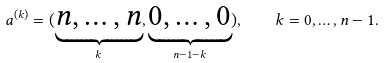<formula> <loc_0><loc_0><loc_500><loc_500>\ a ^ { ( k ) } = ( \underbrace { n , \dots , n } _ { k } , \underbrace { 0 , \dots , 0 } _ { n - 1 - k } ) , \quad k = 0 , \dots , n - 1 .</formula> 